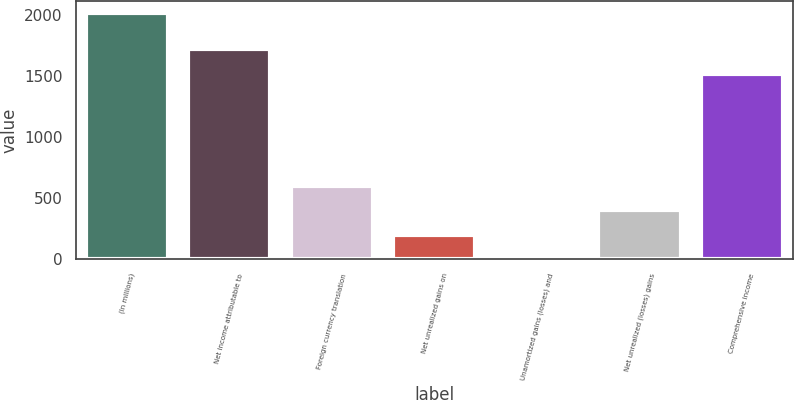Convert chart. <chart><loc_0><loc_0><loc_500><loc_500><bar_chart><fcel>(In millions)<fcel>Net income attributable to<fcel>Foreign currency translation<fcel>Net unrealized gains on<fcel>Unamortized gains (losses) and<fcel>Net unrealized (losses) gains<fcel>Comprehensive income<nl><fcel>2012<fcel>1717.1<fcel>604.3<fcel>202.1<fcel>1<fcel>403.2<fcel>1516<nl></chart> 